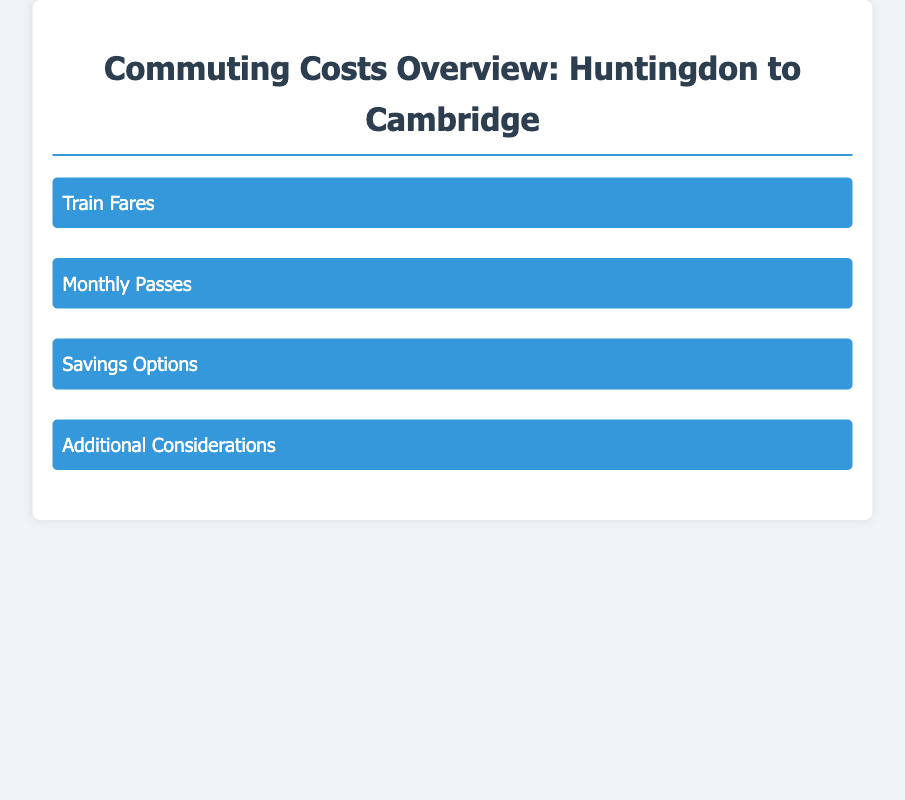What is the Standard Off-Peak Return Fare? The document states that the Standard Off-Peak Return Fare is approximately £10.80.
Answer: £10.80 How much is the Huntingdon to Cambridge Monthly Season Ticket? The document indicates that the Huntingdon to Cambridge Monthly Season Ticket costs approximately £172.00.
Answer: £172.00 What is the savings percentage offered by a Railcard? According to the document, a Railcard can save you 1/3 on fares.
Answer: 1/3 What travel option could lead to savings if booked ahead? The document mentions that booking in advance can lead to significant savings, especially for off-peak travel.
Answer: Off-peak travel What are the parking costs mentioned for Cambridge city center? The document notes that parking fees in Cambridge can exceed £2.50 per hour in city center locations.
Answer: £2.50 What are the train journey minutes from Huntingdon to Cambridge? The document states that the train journey takes approximately 30 minutes.
Answer: 30 minutes What type of ticket allows flexibility with travel times? The document describes the Anytime Return Fare as offering flexibility with travel times.
Answer: Anytime Return Fare What should you check for potential savings on monthly passes? The document advises checking with your HR department for subsidies on monthly passes.
Answer: HR department 